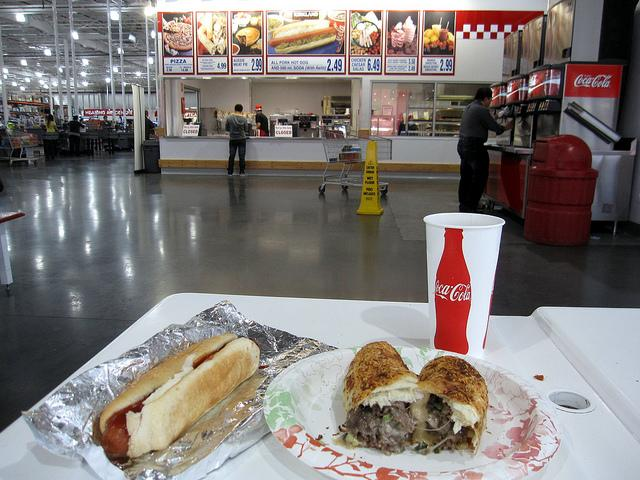Do both options have cheese on them? no 